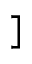Convert formula to latex. <formula><loc_0><loc_0><loc_500><loc_500>]</formula> 